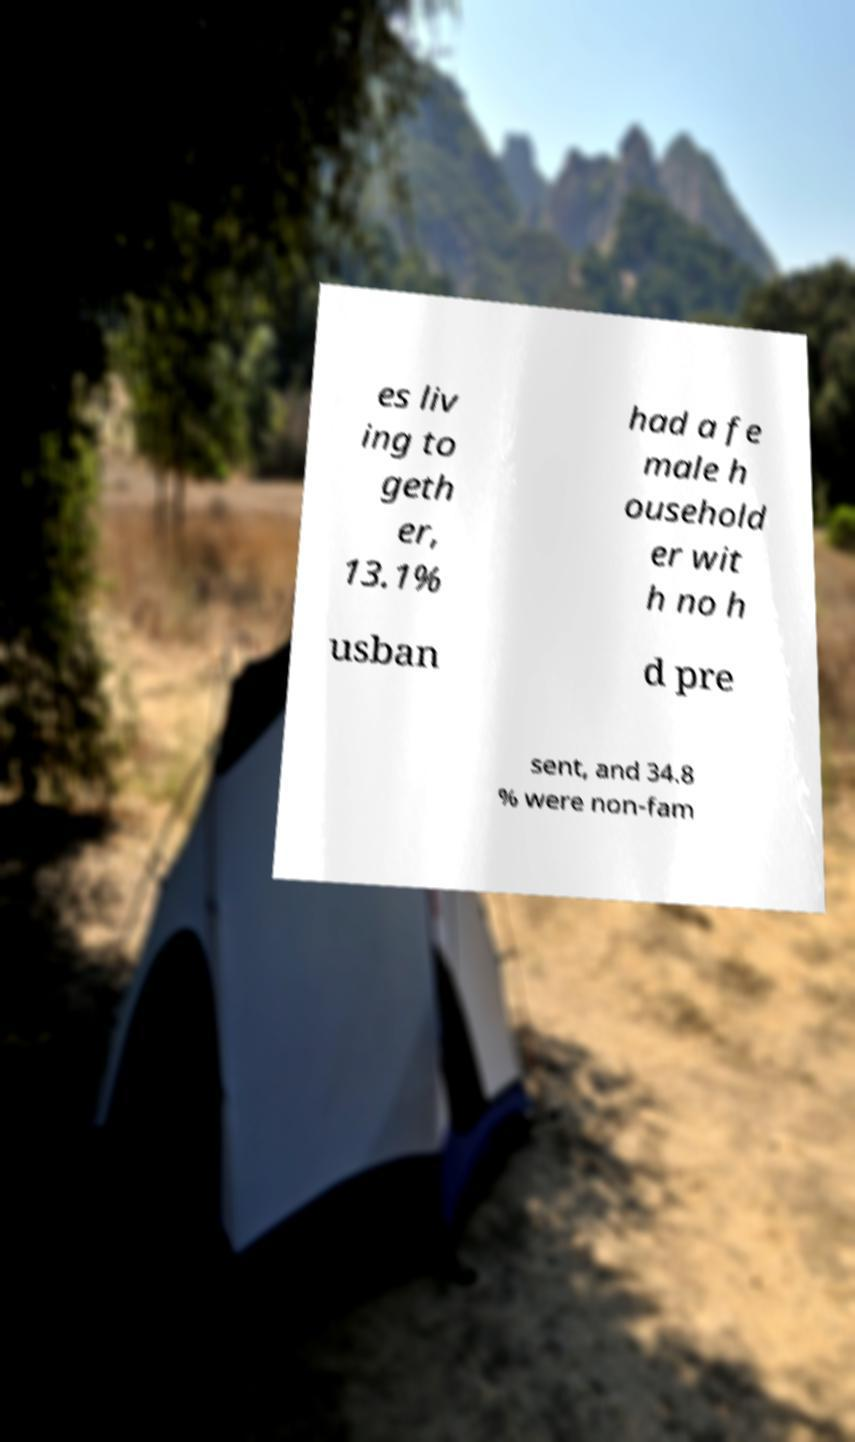Please identify and transcribe the text found in this image. es liv ing to geth er, 13.1% had a fe male h ousehold er wit h no h usban d pre sent, and 34.8 % were non-fam 